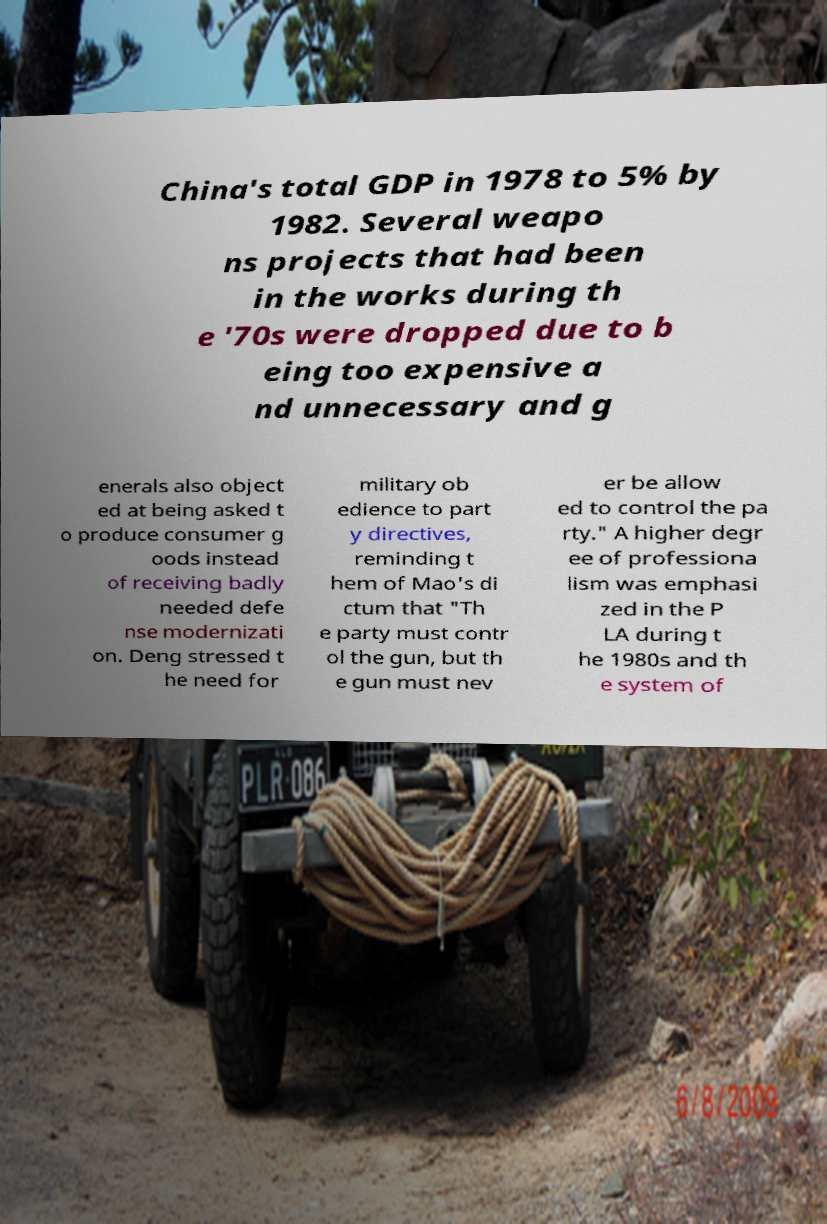Could you assist in decoding the text presented in this image and type it out clearly? China's total GDP in 1978 to 5% by 1982. Several weapo ns projects that had been in the works during th e '70s were dropped due to b eing too expensive a nd unnecessary and g enerals also object ed at being asked t o produce consumer g oods instead of receiving badly needed defe nse modernizati on. Deng stressed t he need for military ob edience to part y directives, reminding t hem of Mao's di ctum that "Th e party must contr ol the gun, but th e gun must nev er be allow ed to control the pa rty." A higher degr ee of professiona lism was emphasi zed in the P LA during t he 1980s and th e system of 